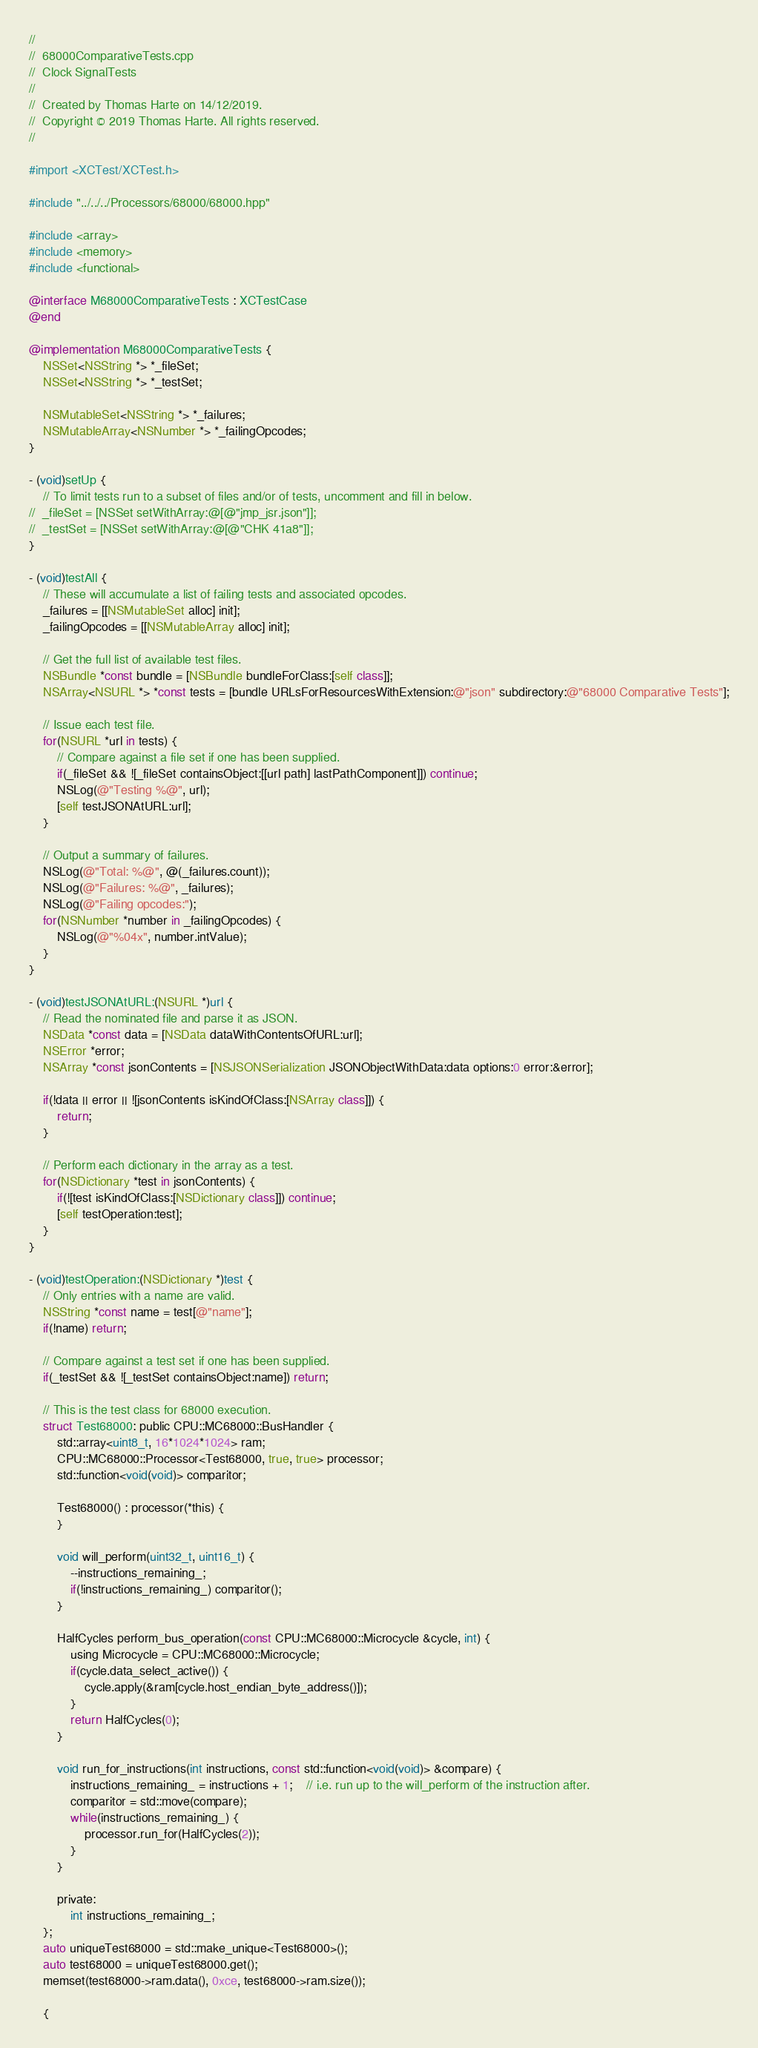Convert code to text. <code><loc_0><loc_0><loc_500><loc_500><_ObjectiveC_>//
//  68000ComparativeTests.cpp
//  Clock SignalTests
//
//  Created by Thomas Harte on 14/12/2019.
//  Copyright © 2019 Thomas Harte. All rights reserved.
//

#import <XCTest/XCTest.h>

#include "../../../Processors/68000/68000.hpp"

#include <array>
#include <memory>
#include <functional>

@interface M68000ComparativeTests : XCTestCase
@end

@implementation M68000ComparativeTests {
	NSSet<NSString *> *_fileSet;
	NSSet<NSString *> *_testSet;

	NSMutableSet<NSString *> *_failures;
	NSMutableArray<NSNumber *> *_failingOpcodes;
}

- (void)setUp {
	// To limit tests run to a subset of files and/or of tests, uncomment and fill in below.
//	_fileSet = [NSSet setWithArray:@[@"jmp_jsr.json"]];
//	_testSet = [NSSet setWithArray:@[@"CHK 41a8"]];
}

- (void)testAll {
	// These will accumulate a list of failing tests and associated opcodes.
	_failures = [[NSMutableSet alloc] init];
	_failingOpcodes = [[NSMutableArray alloc] init];

	// Get the full list of available test files.
	NSBundle *const bundle = [NSBundle bundleForClass:[self class]];
	NSArray<NSURL *> *const tests = [bundle URLsForResourcesWithExtension:@"json" subdirectory:@"68000 Comparative Tests"];

	// Issue each test file.
	for(NSURL *url in tests) {
		// Compare against a file set if one has been supplied.
		if(_fileSet && ![_fileSet containsObject:[[url path] lastPathComponent]]) continue;
		NSLog(@"Testing %@", url);
		[self testJSONAtURL:url];
	}

	// Output a summary of failures.
	NSLog(@"Total: %@", @(_failures.count));
	NSLog(@"Failures: %@", _failures);
	NSLog(@"Failing opcodes:");
	for(NSNumber *number in _failingOpcodes) {
		NSLog(@"%04x", number.intValue);
	}
}

- (void)testJSONAtURL:(NSURL *)url {
	// Read the nominated file and parse it as JSON.
	NSData *const data = [NSData dataWithContentsOfURL:url];
	NSError *error;
	NSArray *const jsonContents = [NSJSONSerialization JSONObjectWithData:data options:0 error:&error];

	if(!data || error || ![jsonContents isKindOfClass:[NSArray class]]) {
		return;
	}

	// Perform each dictionary in the array as a test.
	for(NSDictionary *test in jsonContents) {
		if(![test isKindOfClass:[NSDictionary class]]) continue;
		[self testOperation:test];
	}
}

- (void)testOperation:(NSDictionary *)test {
	// Only entries with a name are valid.
	NSString *const name = test[@"name"];
	if(!name) return;

	// Compare against a test set if one has been supplied.
	if(_testSet && ![_testSet containsObject:name]) return;

	// This is the test class for 68000 execution.
	struct Test68000: public CPU::MC68000::BusHandler {
		std::array<uint8_t, 16*1024*1024> ram;
		CPU::MC68000::Processor<Test68000, true, true> processor;
		std::function<void(void)> comparitor;

		Test68000() : processor(*this) {
		}

		void will_perform(uint32_t, uint16_t) {
			--instructions_remaining_;
			if(!instructions_remaining_) comparitor();
		}

		HalfCycles perform_bus_operation(const CPU::MC68000::Microcycle &cycle, int) {
			using Microcycle = CPU::MC68000::Microcycle;
			if(cycle.data_select_active()) {
				cycle.apply(&ram[cycle.host_endian_byte_address()]);
			}
			return HalfCycles(0);
		}

		void run_for_instructions(int instructions, const std::function<void(void)> &compare) {
			instructions_remaining_ = instructions + 1;	// i.e. run up to the will_perform of the instruction after.
			comparitor = std::move(compare);
			while(instructions_remaining_) {
				processor.run_for(HalfCycles(2));
			}
		}

		private:
			int instructions_remaining_;
	};
	auto uniqueTest68000 = std::make_unique<Test68000>();
	auto test68000 = uniqueTest68000.get();
	memset(test68000->ram.data(), 0xce, test68000->ram.size());

	{</code> 